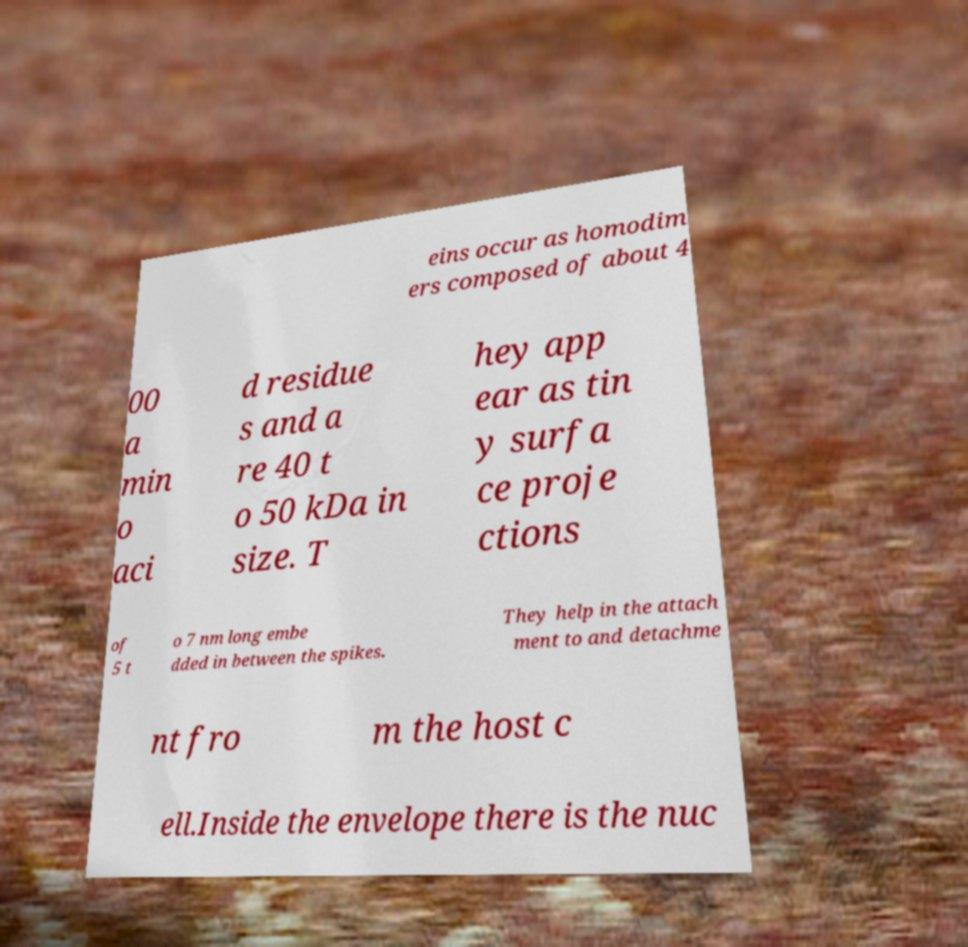There's text embedded in this image that I need extracted. Can you transcribe it verbatim? eins occur as homodim ers composed of about 4 00 a min o aci d residue s and a re 40 t o 50 kDa in size. T hey app ear as tin y surfa ce proje ctions of 5 t o 7 nm long embe dded in between the spikes. They help in the attach ment to and detachme nt fro m the host c ell.Inside the envelope there is the nuc 